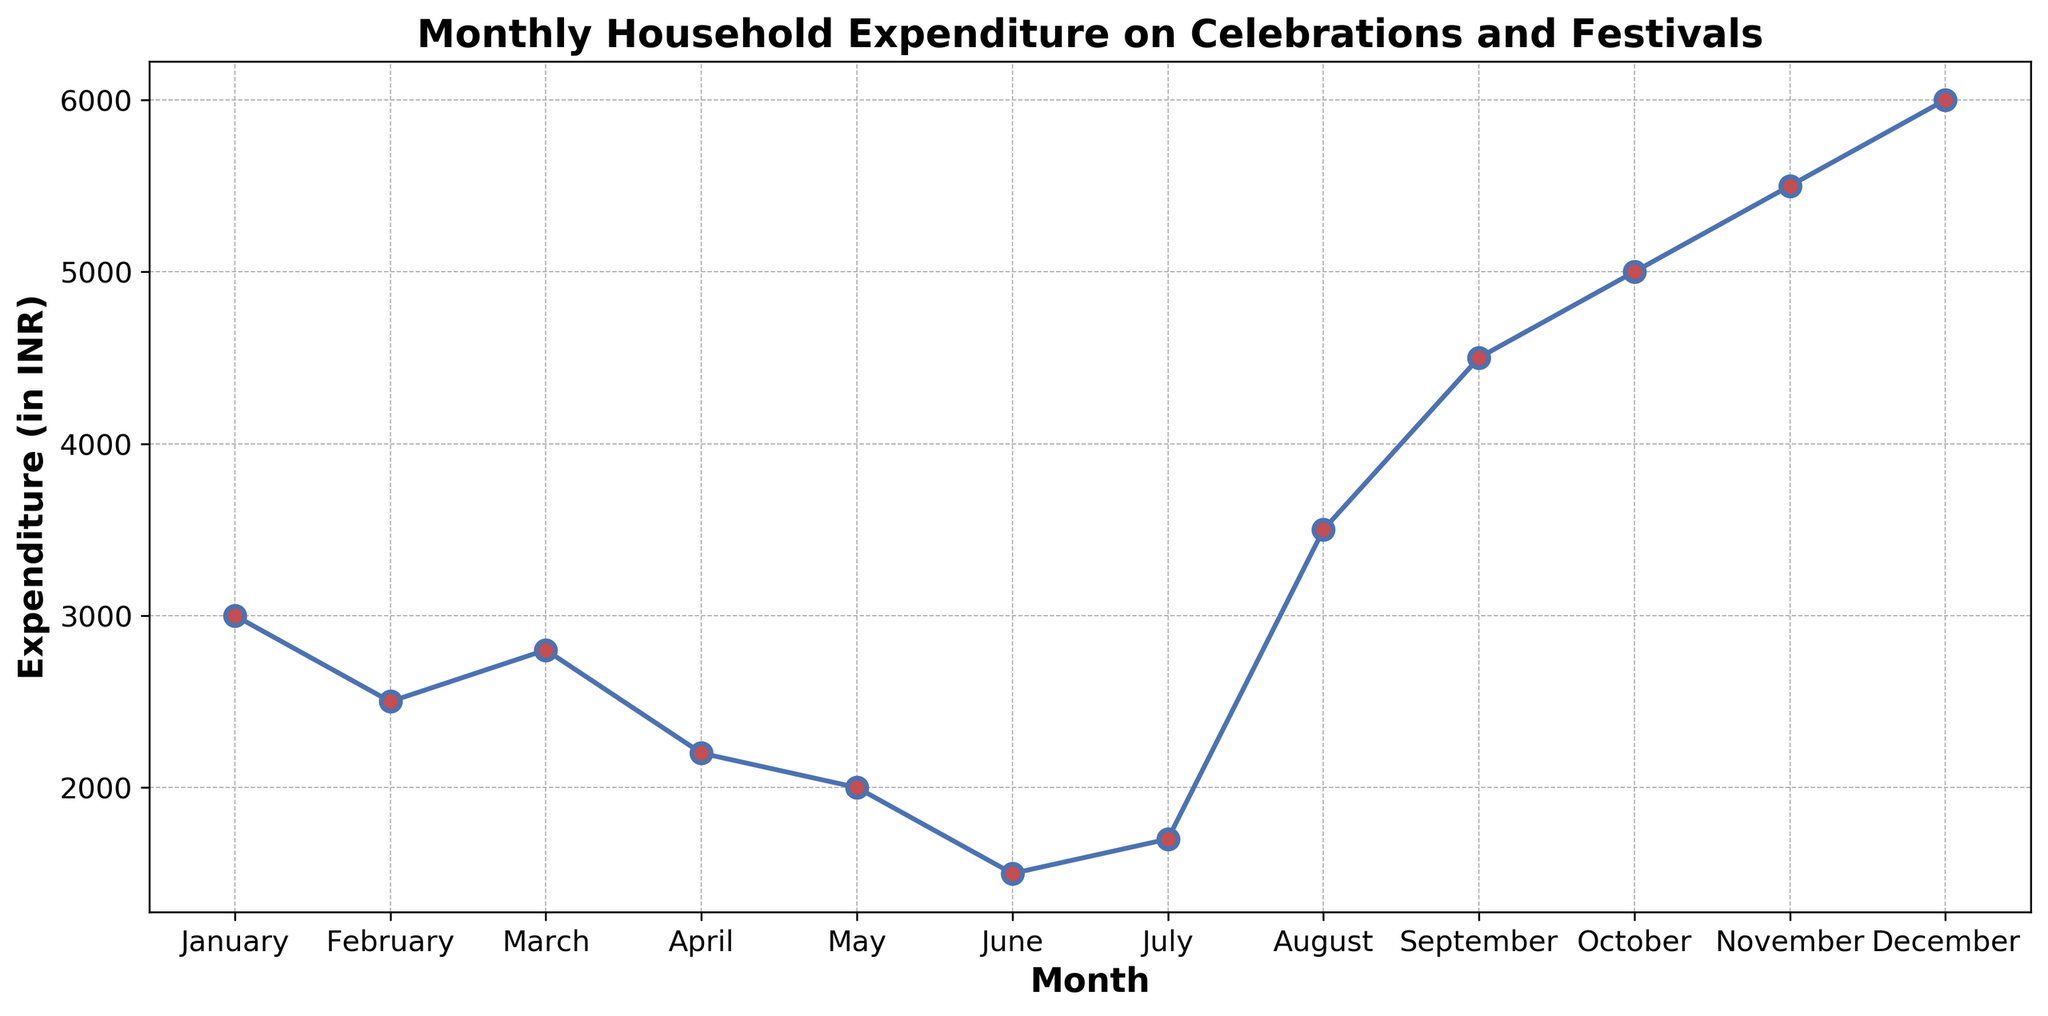Which month has the highest household expenditure on celebrations and festivals? The highest point on the line chart indicates the highest expenditure. December's point is the highest on the chart.
Answer: December What is the expenditure difference between November and May? The expenditure in November is 5500 INR and in May it is 2000 INR. To find the difference, subtract the expenditure in May from the expenditure in November: 5500 - 2000 = 3500 INR.
Answer: 3500 INR What is the average monthly household expenditure over the year? To calculate the average, sum all the monthly expenditures, then divide by the number of months. Sum: 3000 + 2500 + 2800 + 2200 + 2000 + 1500 + 1700 + 3500 + 4500 + 5000 + 5500 + 6000 = 43200. Divide by 12: 43200 / 12 = 3600 INR.
Answer: 3600 INR Which months have an expenditure greater than 4000 INR? By looking at the points on the chart and their corresponding values, the months with an expenditure greater than 4000 INR are September (4500), October (5000), November (5500), and December (6000).
Answer: September, October, November, December What is the trend of household expenditure between January and June? Observing the line from January to June, there is a general decrease in expenditure over these months. January starts at 3000 INR and decreases to 1500 INR in June.
Answer: Decreasing trend How does the expenditure in August compare to that in February? The expenditure in August is 3500 INR and in February it is 2500 INR. Comparing these values, August's expenditure is higher than February's.
Answer: August is higher Calculate the total expenditure for the first quarter (January, February, March). Sum the expenditures of January (3000), February (2500), and March (2800): 3000 + 2500 + 2800 = 8300 INR.
Answer: 8300 INR Which month saw the lowest expenditure? The lowest point on the line chart indicates the lowest expenditure. June's point is the lowest on the chart.
Answer: June 